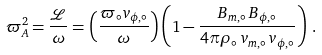<formula> <loc_0><loc_0><loc_500><loc_500>\varpi _ { A } ^ { 2 } = \frac { \mathcal { L } } { \omega } = \left ( \frac { \varpi _ { \circ } v _ { \phi , \circ } } { \omega } \right ) \left ( 1 - \frac { B _ { m , \circ } \, B _ { \phi , \circ } } { 4 \pi \rho _ { \circ } \, v _ { m , \circ } \, v _ { \phi , \circ } } \right ) \, .</formula> 